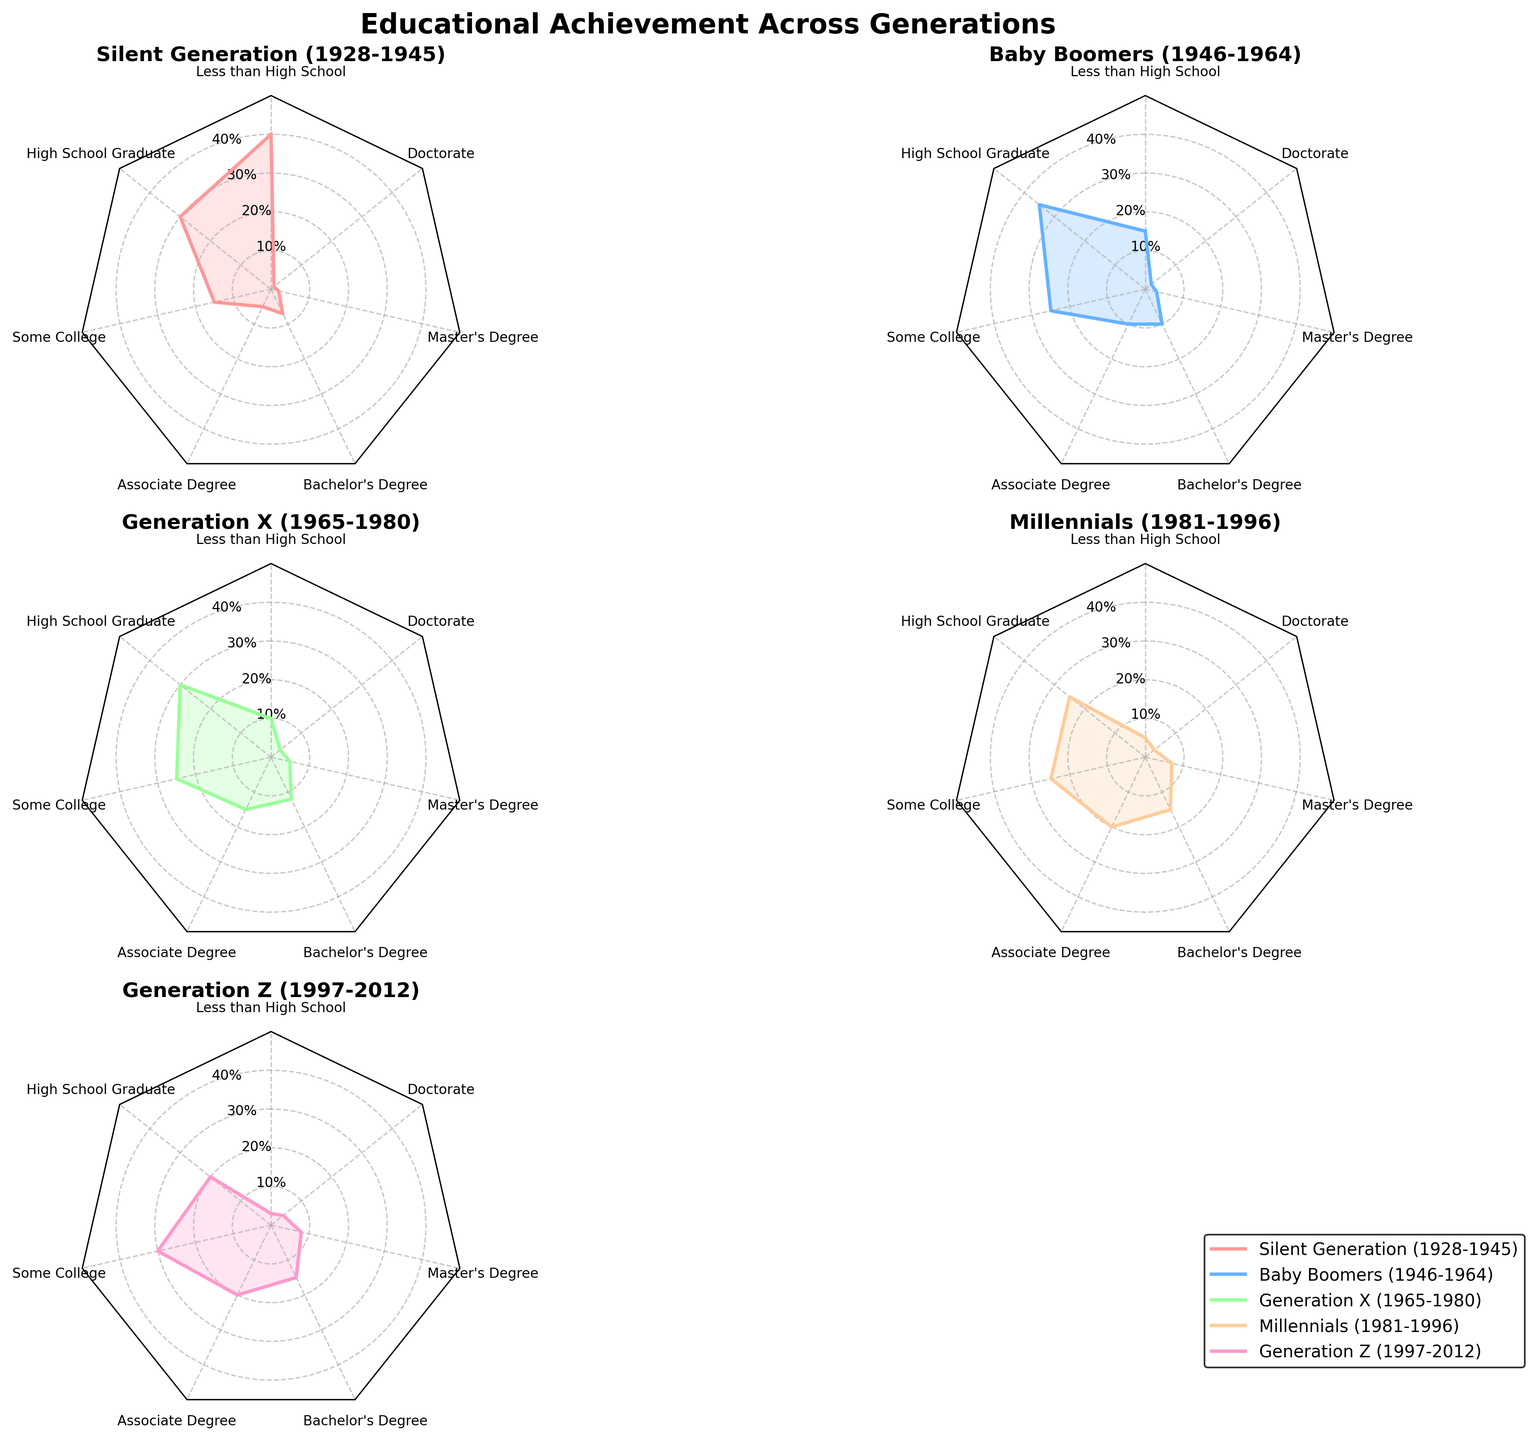Which generation has the highest percentage of individuals with less than a high school education? By examining the subplot for "Less than High School," it's clear that the Silent Generation (1928-1945) has the highest percentage.
Answer: Silent Generation Between Generation X and Millennials, which group has a higher percentage of individuals with an Associate Degree? By comparing the subplots for "Associate Degree," Millennials have a higher percentage (20%) compared to Generation X (15%).
Answer: Millennials What is the total percentage of educational attainment levels (all categories combined) for Baby Boomers? Sum the percentages across all educational attainment levels for Baby Boomers: 15 + 35 + 25 + 10 + 10 + 3 + 2 = 100%.
Answer: 100% Which educational achievement level is consistently increasing across the generations? By examining all subplots, "Bachelor's Degree" is consistently increasing from the Silent Generation to Generation Z.
Answer: Bachelor's Degree How does the percentage of Master's Degree holders compare between Generation Z and Baby Boomers? The subplot for "Master's Degree" shows that Generation Z (8%) has a higher percentage compared to Baby Boomers (3%).
Answer: Generation Z Which generation has the lowest percentage of high school graduates? Comparing the subplots for "High School Graduate," Generation Z has the lowest percentage at 20%.
Answer: Generation Z What's the difference in the percentage of individuals with some college education between Millennials and the Silent Generation? The subplot for "Some College" indicates Millennials have 25% while the Silent Generation has 15%. The difference is 25% - 15% = 10%.
Answer: 10% If you were to average the percentage of Doctorate holders across all generations, what would it be? Sum the percentages for "Doctorate" across all generations and then divide by the number of generations: (1 + 2 + 3 + 3 + 4) / 5 = 2.6%.
Answer: 2.6% Which generation has the most evenly distributed percentages across all educational achievement levels? By visually inspecting the balance of subplots, Generation X has values that are fairly evenly distributed relative to other generations.
Answer: Generation X 